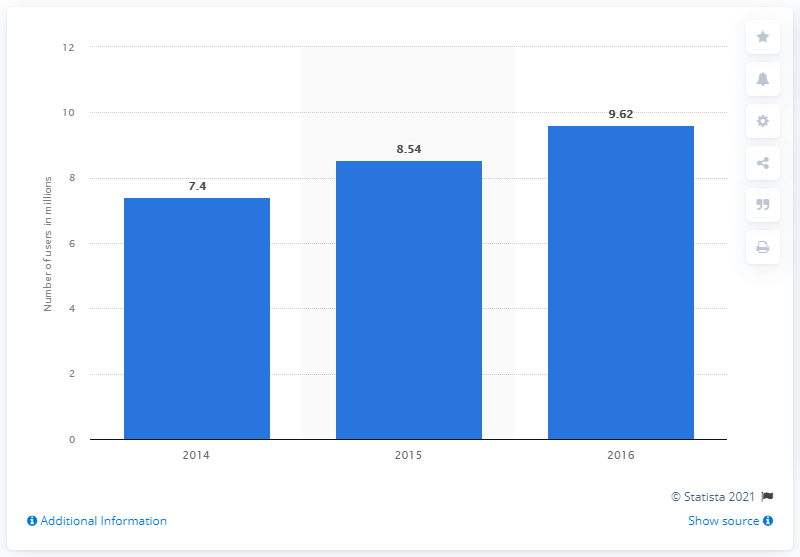Draw attention to some important aspects in this diagram. In 2016, there were approximately 8.54 million Twitter users in Mexico. 